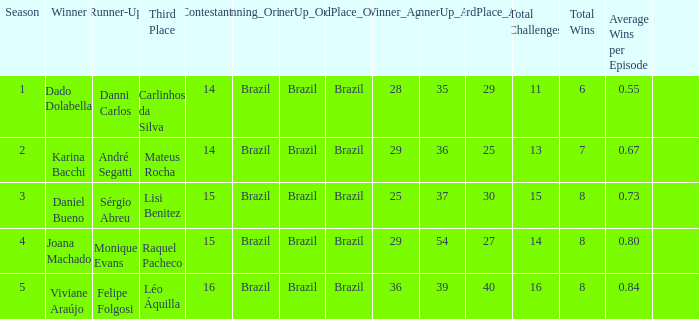In what season did Raquel Pacheco finish in third place? 4.0. 